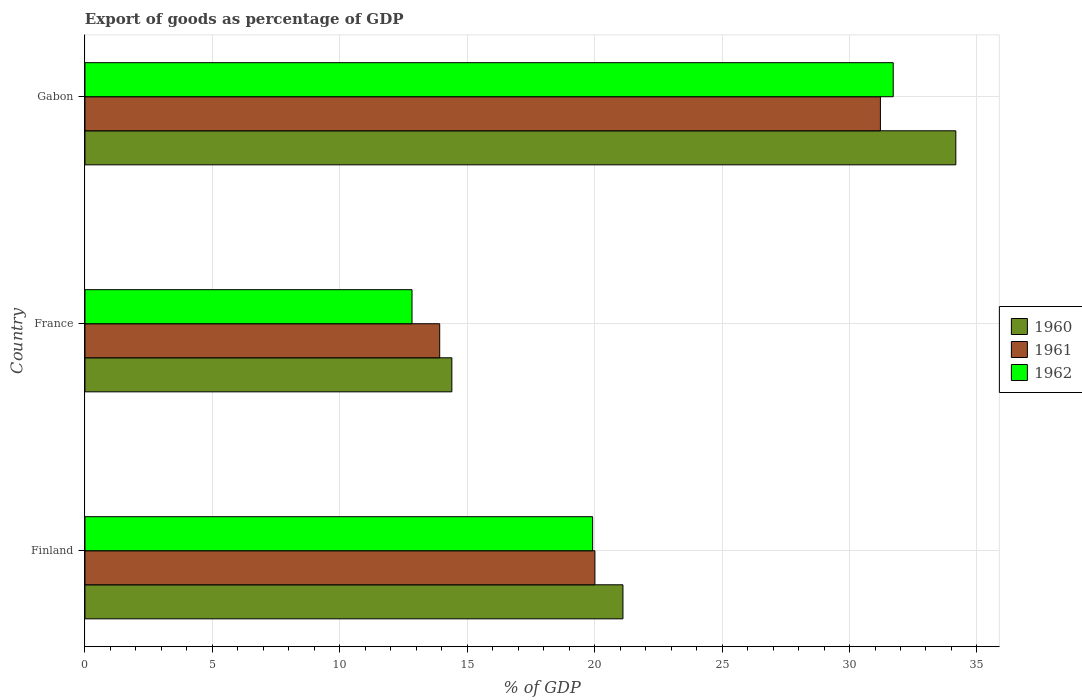How many different coloured bars are there?
Give a very brief answer. 3. Are the number of bars on each tick of the Y-axis equal?
Provide a short and direct response. Yes. How many bars are there on the 3rd tick from the top?
Give a very brief answer. 3. In how many cases, is the number of bars for a given country not equal to the number of legend labels?
Ensure brevity in your answer.  0. What is the export of goods as percentage of GDP in 1960 in Finland?
Your response must be concise. 21.11. Across all countries, what is the maximum export of goods as percentage of GDP in 1962?
Offer a very short reply. 31.71. Across all countries, what is the minimum export of goods as percentage of GDP in 1960?
Your response must be concise. 14.4. In which country was the export of goods as percentage of GDP in 1962 maximum?
Give a very brief answer. Gabon. What is the total export of goods as percentage of GDP in 1960 in the graph?
Provide a short and direct response. 69.68. What is the difference between the export of goods as percentage of GDP in 1960 in Finland and that in Gabon?
Your response must be concise. -13.06. What is the difference between the export of goods as percentage of GDP in 1961 in Gabon and the export of goods as percentage of GDP in 1962 in France?
Your answer should be very brief. 18.38. What is the average export of goods as percentage of GDP in 1960 per country?
Ensure brevity in your answer.  23.23. What is the difference between the export of goods as percentage of GDP in 1960 and export of goods as percentage of GDP in 1961 in France?
Provide a succinct answer. 0.48. In how many countries, is the export of goods as percentage of GDP in 1962 greater than 15 %?
Provide a short and direct response. 2. What is the ratio of the export of goods as percentage of GDP in 1961 in Finland to that in France?
Provide a short and direct response. 1.44. What is the difference between the highest and the second highest export of goods as percentage of GDP in 1962?
Your answer should be very brief. 11.79. What is the difference between the highest and the lowest export of goods as percentage of GDP in 1960?
Ensure brevity in your answer.  19.77. In how many countries, is the export of goods as percentage of GDP in 1961 greater than the average export of goods as percentage of GDP in 1961 taken over all countries?
Make the answer very short. 1. Is the sum of the export of goods as percentage of GDP in 1962 in France and Gabon greater than the maximum export of goods as percentage of GDP in 1961 across all countries?
Offer a terse response. Yes. What does the 1st bar from the top in France represents?
Your answer should be very brief. 1962. Is it the case that in every country, the sum of the export of goods as percentage of GDP in 1961 and export of goods as percentage of GDP in 1962 is greater than the export of goods as percentage of GDP in 1960?
Make the answer very short. Yes. Does the graph contain grids?
Provide a short and direct response. Yes. How are the legend labels stacked?
Provide a succinct answer. Vertical. What is the title of the graph?
Give a very brief answer. Export of goods as percentage of GDP. Does "1986" appear as one of the legend labels in the graph?
Provide a succinct answer. No. What is the label or title of the X-axis?
Give a very brief answer. % of GDP. What is the label or title of the Y-axis?
Your response must be concise. Country. What is the % of GDP of 1960 in Finland?
Provide a short and direct response. 21.11. What is the % of GDP in 1961 in Finland?
Your answer should be very brief. 20.01. What is the % of GDP in 1962 in Finland?
Provide a short and direct response. 19.92. What is the % of GDP in 1960 in France?
Provide a short and direct response. 14.4. What is the % of GDP in 1961 in France?
Make the answer very short. 13.92. What is the % of GDP of 1962 in France?
Make the answer very short. 12.83. What is the % of GDP in 1960 in Gabon?
Your response must be concise. 34.17. What is the % of GDP in 1961 in Gabon?
Keep it short and to the point. 31.21. What is the % of GDP of 1962 in Gabon?
Offer a terse response. 31.71. Across all countries, what is the maximum % of GDP in 1960?
Make the answer very short. 34.17. Across all countries, what is the maximum % of GDP of 1961?
Offer a terse response. 31.21. Across all countries, what is the maximum % of GDP of 1962?
Ensure brevity in your answer.  31.71. Across all countries, what is the minimum % of GDP of 1960?
Keep it short and to the point. 14.4. Across all countries, what is the minimum % of GDP of 1961?
Your answer should be very brief. 13.92. Across all countries, what is the minimum % of GDP in 1962?
Your answer should be compact. 12.83. What is the total % of GDP in 1960 in the graph?
Provide a succinct answer. 69.68. What is the total % of GDP in 1961 in the graph?
Offer a terse response. 65.14. What is the total % of GDP of 1962 in the graph?
Offer a terse response. 64.47. What is the difference between the % of GDP in 1960 in Finland and that in France?
Provide a short and direct response. 6.71. What is the difference between the % of GDP in 1961 in Finland and that in France?
Your answer should be compact. 6.09. What is the difference between the % of GDP in 1962 in Finland and that in France?
Provide a short and direct response. 7.09. What is the difference between the % of GDP in 1960 in Finland and that in Gabon?
Keep it short and to the point. -13.06. What is the difference between the % of GDP in 1961 in Finland and that in Gabon?
Provide a short and direct response. -11.2. What is the difference between the % of GDP in 1962 in Finland and that in Gabon?
Ensure brevity in your answer.  -11.79. What is the difference between the % of GDP of 1960 in France and that in Gabon?
Keep it short and to the point. -19.77. What is the difference between the % of GDP of 1961 in France and that in Gabon?
Offer a terse response. -17.29. What is the difference between the % of GDP in 1962 in France and that in Gabon?
Offer a very short reply. -18.88. What is the difference between the % of GDP of 1960 in Finland and the % of GDP of 1961 in France?
Offer a very short reply. 7.19. What is the difference between the % of GDP in 1960 in Finland and the % of GDP in 1962 in France?
Your response must be concise. 8.28. What is the difference between the % of GDP in 1961 in Finland and the % of GDP in 1962 in France?
Your response must be concise. 7.18. What is the difference between the % of GDP of 1960 in Finland and the % of GDP of 1961 in Gabon?
Your answer should be compact. -10.1. What is the difference between the % of GDP in 1960 in Finland and the % of GDP in 1962 in Gabon?
Offer a very short reply. -10.6. What is the difference between the % of GDP of 1961 in Finland and the % of GDP of 1962 in Gabon?
Give a very brief answer. -11.7. What is the difference between the % of GDP of 1960 in France and the % of GDP of 1961 in Gabon?
Your response must be concise. -16.82. What is the difference between the % of GDP of 1960 in France and the % of GDP of 1962 in Gabon?
Ensure brevity in your answer.  -17.32. What is the difference between the % of GDP of 1961 in France and the % of GDP of 1962 in Gabon?
Your answer should be very brief. -17.8. What is the average % of GDP of 1960 per country?
Your answer should be very brief. 23.23. What is the average % of GDP in 1961 per country?
Your answer should be compact. 21.71. What is the average % of GDP in 1962 per country?
Your response must be concise. 21.49. What is the difference between the % of GDP of 1960 and % of GDP of 1961 in Finland?
Offer a very short reply. 1.1. What is the difference between the % of GDP of 1960 and % of GDP of 1962 in Finland?
Ensure brevity in your answer.  1.19. What is the difference between the % of GDP of 1961 and % of GDP of 1962 in Finland?
Provide a succinct answer. 0.09. What is the difference between the % of GDP in 1960 and % of GDP in 1961 in France?
Keep it short and to the point. 0.48. What is the difference between the % of GDP of 1960 and % of GDP of 1962 in France?
Offer a terse response. 1.56. What is the difference between the % of GDP of 1961 and % of GDP of 1962 in France?
Provide a short and direct response. 1.09. What is the difference between the % of GDP of 1960 and % of GDP of 1961 in Gabon?
Provide a succinct answer. 2.96. What is the difference between the % of GDP in 1960 and % of GDP in 1962 in Gabon?
Keep it short and to the point. 2.46. What is the difference between the % of GDP in 1961 and % of GDP in 1962 in Gabon?
Provide a succinct answer. -0.5. What is the ratio of the % of GDP of 1960 in Finland to that in France?
Your response must be concise. 1.47. What is the ratio of the % of GDP in 1961 in Finland to that in France?
Your answer should be compact. 1.44. What is the ratio of the % of GDP of 1962 in Finland to that in France?
Your response must be concise. 1.55. What is the ratio of the % of GDP of 1960 in Finland to that in Gabon?
Offer a very short reply. 0.62. What is the ratio of the % of GDP in 1961 in Finland to that in Gabon?
Make the answer very short. 0.64. What is the ratio of the % of GDP of 1962 in Finland to that in Gabon?
Make the answer very short. 0.63. What is the ratio of the % of GDP of 1960 in France to that in Gabon?
Give a very brief answer. 0.42. What is the ratio of the % of GDP in 1961 in France to that in Gabon?
Your answer should be very brief. 0.45. What is the ratio of the % of GDP of 1962 in France to that in Gabon?
Offer a very short reply. 0.4. What is the difference between the highest and the second highest % of GDP of 1960?
Provide a succinct answer. 13.06. What is the difference between the highest and the second highest % of GDP of 1961?
Provide a succinct answer. 11.2. What is the difference between the highest and the second highest % of GDP in 1962?
Keep it short and to the point. 11.79. What is the difference between the highest and the lowest % of GDP in 1960?
Provide a short and direct response. 19.77. What is the difference between the highest and the lowest % of GDP of 1961?
Offer a very short reply. 17.29. What is the difference between the highest and the lowest % of GDP in 1962?
Your answer should be compact. 18.88. 